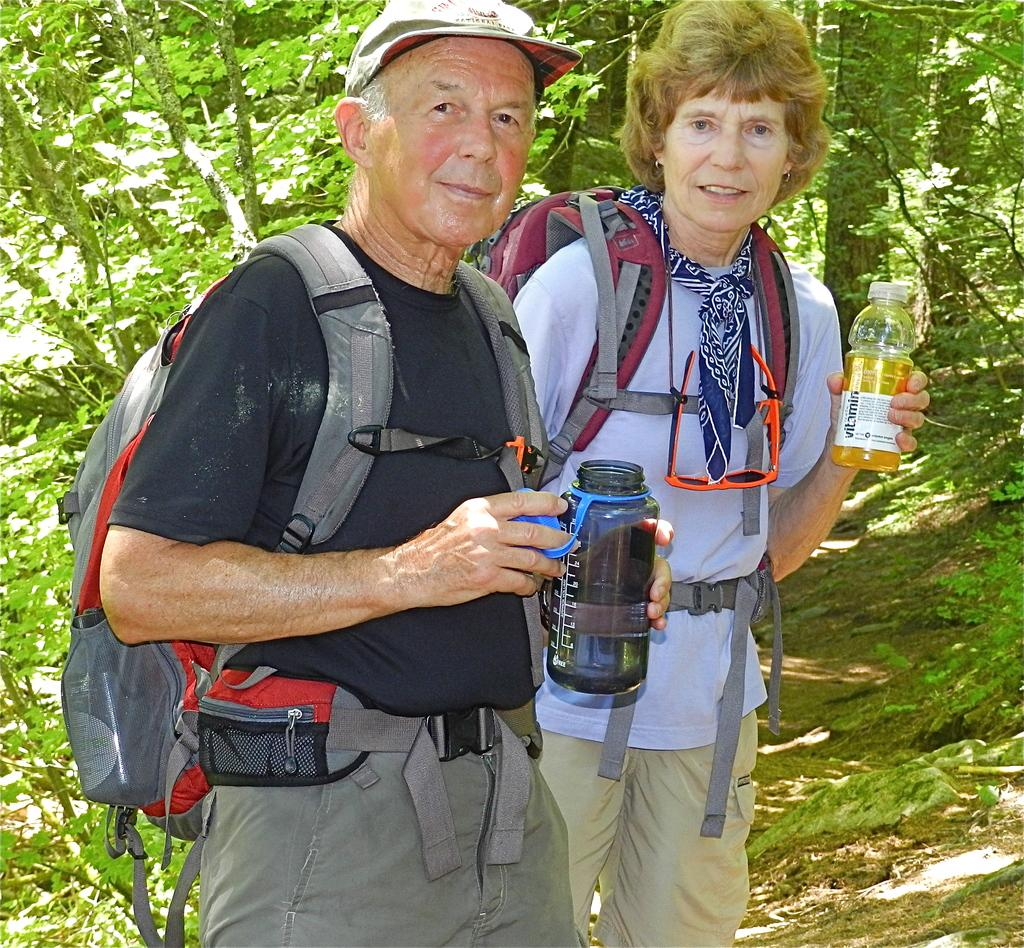How many people are present in the image? There are two people, a man and a woman, present in the image. What are the man and woman wearing in the image? The man and woman are both wearing bags in the image. What are the man and woman holding in the image? The man and woman are both holding bottles in the image. What can be seen in the background of the image? There is a tree in the background of the image. What type of yoke is the man using to carry the bottles in the image? There is no yoke present in the image; the man is simply holding the bottles. What type of soda is the woman drinking from the bottle in the image? There is no indication of the type of beverage in the bottle, as the contents are not visible in the image. 